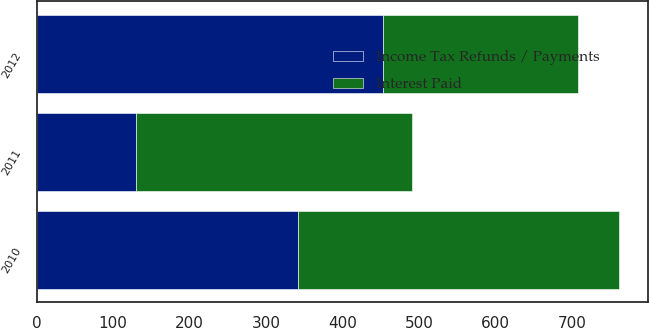Convert chart. <chart><loc_0><loc_0><loc_500><loc_500><stacked_bar_chart><ecel><fcel>2012<fcel>2011<fcel>2010<nl><fcel>Interest Paid<fcel>255<fcel>361<fcel>419<nl><fcel>Income Tax Refunds / Payments<fcel>453<fcel>130<fcel>342<nl></chart> 